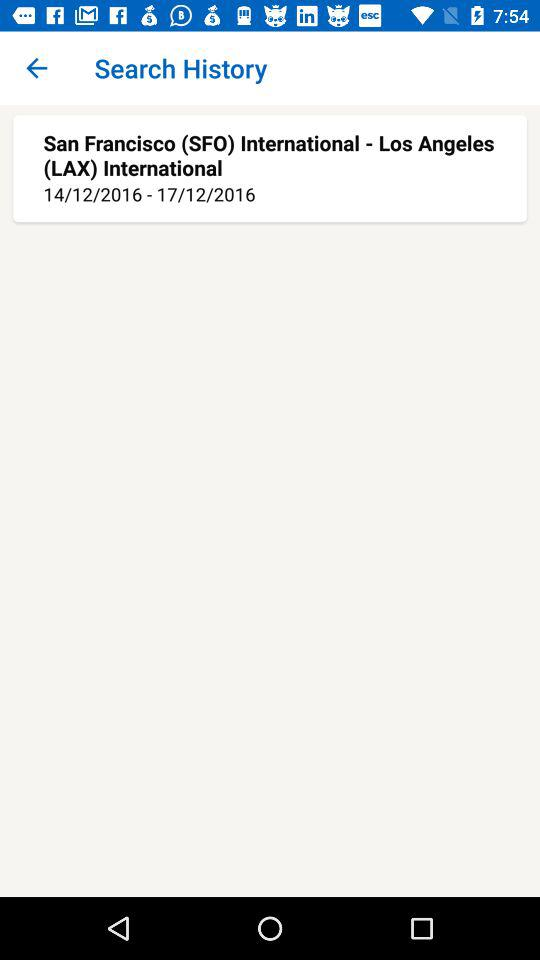How many days is the trip?
Answer the question using a single word or phrase. 3 